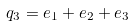Convert formula to latex. <formula><loc_0><loc_0><loc_500><loc_500>q _ { 3 } = e _ { 1 } + e _ { 2 } + e _ { 3 }</formula> 